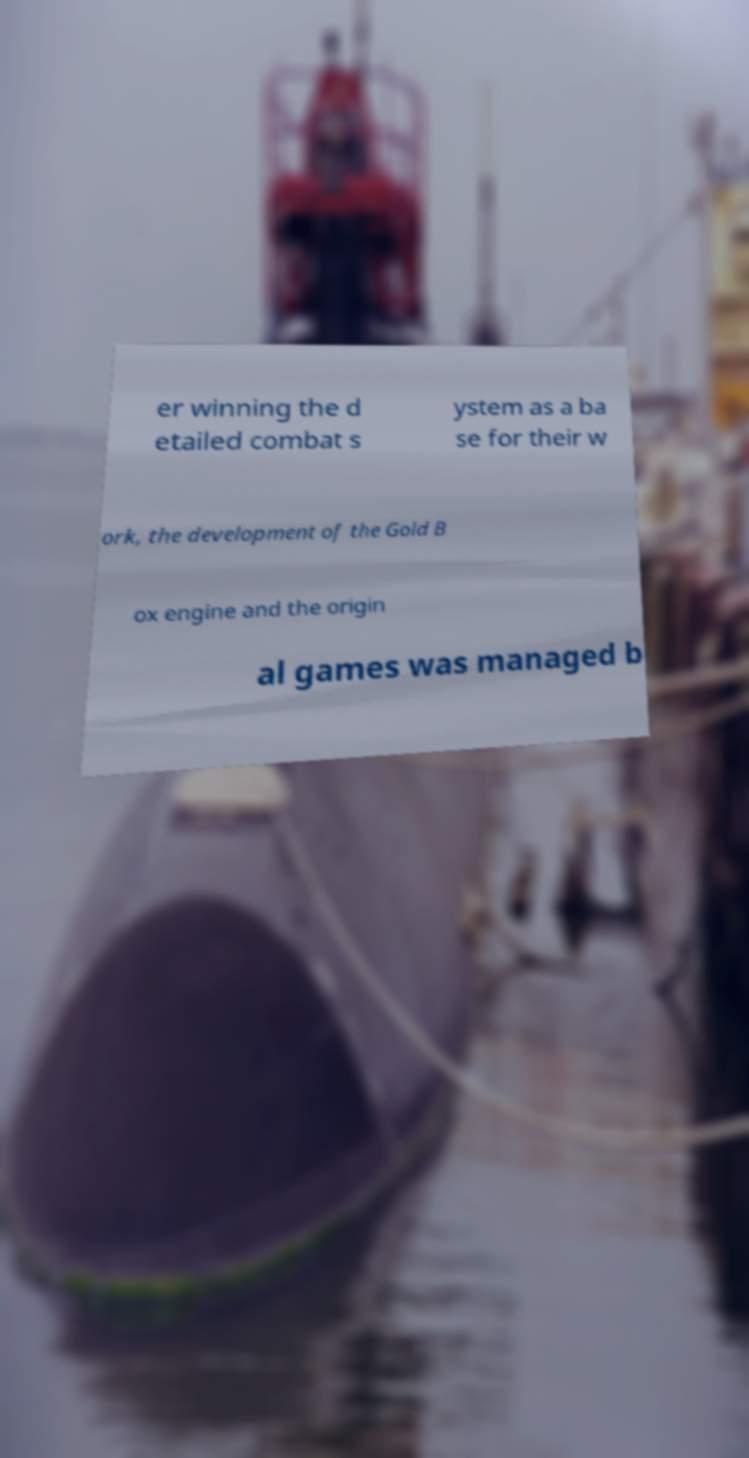I need the written content from this picture converted into text. Can you do that? er winning the d etailed combat s ystem as a ba se for their w ork, the development of the Gold B ox engine and the origin al games was managed b 